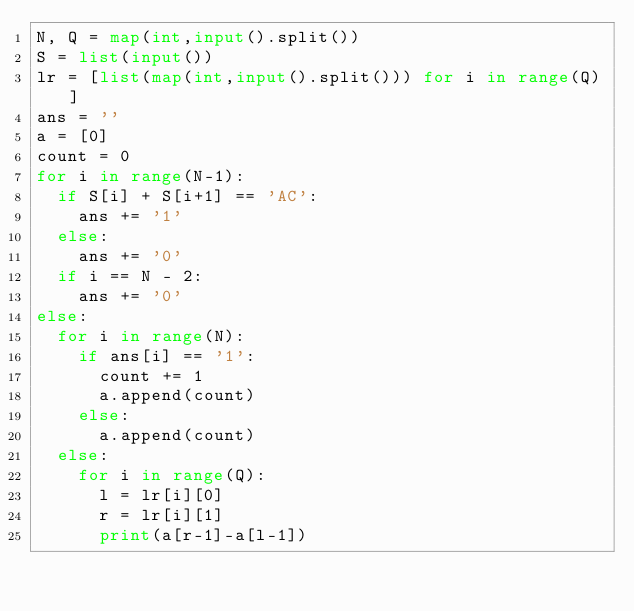<code> <loc_0><loc_0><loc_500><loc_500><_Python_>N, Q = map(int,input().split())
S = list(input())
lr = [list(map(int,input().split())) for i in range(Q)]
ans = ''
a = [0]
count = 0
for i in range(N-1):
  if S[i] + S[i+1] == 'AC':
    ans += '1'
  else:
    ans += '0'
  if i == N - 2:
    ans += '0'
else:
  for i in range(N):
    if ans[i] == '1':
      count += 1
      a.append(count)
    else:
      a.append(count)
  else:
    for i in range(Q):
      l = lr[i][0]
      r = lr[i][1]
      print(a[r-1]-a[l-1])</code> 